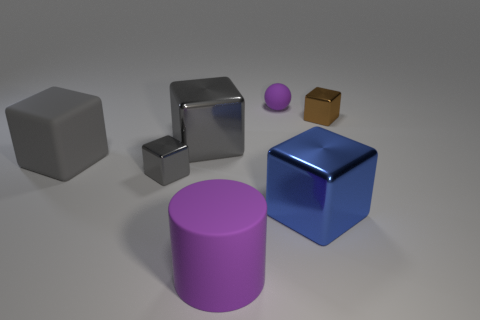Subtract all brown cylinders. How many gray cubes are left? 3 Subtract 1 blocks. How many blocks are left? 4 Subtract all blue cubes. How many cubes are left? 4 Subtract all matte cubes. How many cubes are left? 4 Subtract all yellow cubes. Subtract all cyan cylinders. How many cubes are left? 5 Add 1 tiny purple matte balls. How many objects exist? 8 Subtract all balls. How many objects are left? 6 Subtract 0 cyan cubes. How many objects are left? 7 Subtract all big gray rubber balls. Subtract all small brown shiny things. How many objects are left? 6 Add 5 large purple matte objects. How many large purple matte objects are left? 6 